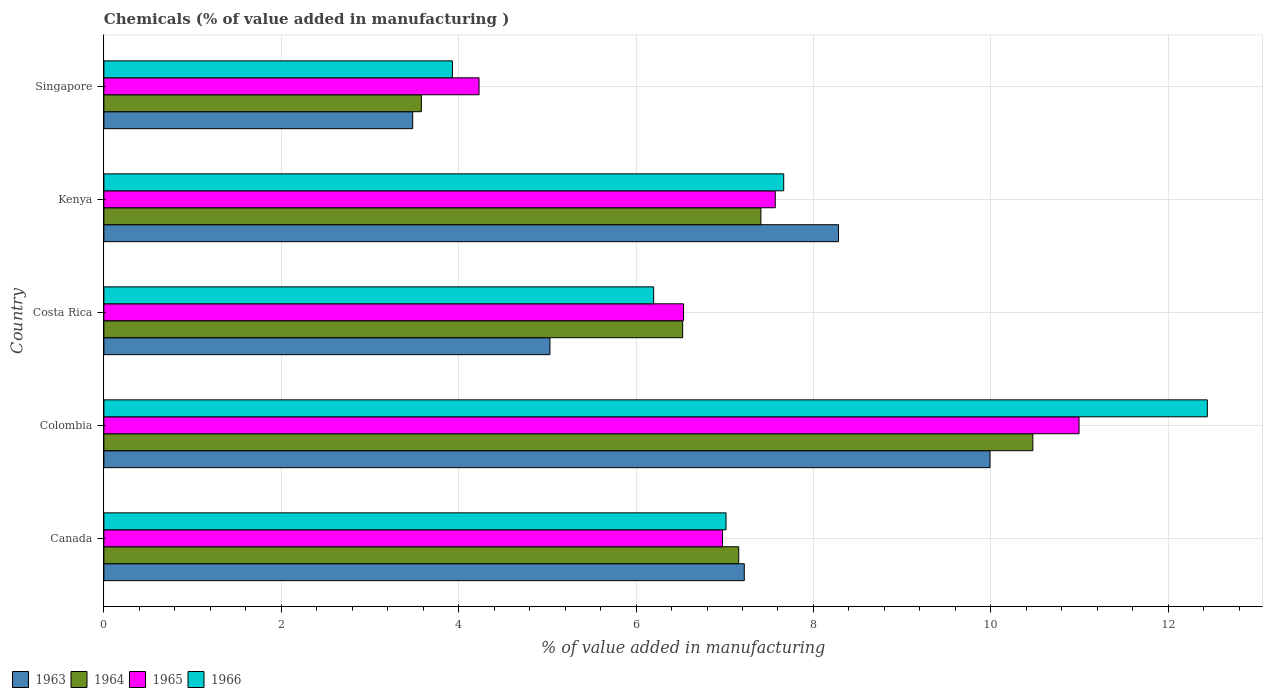How many different coloured bars are there?
Ensure brevity in your answer.  4. Are the number of bars on each tick of the Y-axis equal?
Make the answer very short. Yes. In how many cases, is the number of bars for a given country not equal to the number of legend labels?
Provide a short and direct response. 0. What is the value added in manufacturing chemicals in 1965 in Costa Rica?
Keep it short and to the point. 6.54. Across all countries, what is the maximum value added in manufacturing chemicals in 1965?
Your response must be concise. 10.99. Across all countries, what is the minimum value added in manufacturing chemicals in 1965?
Offer a very short reply. 4.23. In which country was the value added in manufacturing chemicals in 1963 maximum?
Offer a terse response. Colombia. In which country was the value added in manufacturing chemicals in 1965 minimum?
Offer a terse response. Singapore. What is the total value added in manufacturing chemicals in 1963 in the graph?
Give a very brief answer. 34.01. What is the difference between the value added in manufacturing chemicals in 1966 in Canada and that in Kenya?
Provide a succinct answer. -0.65. What is the difference between the value added in manufacturing chemicals in 1963 in Kenya and the value added in manufacturing chemicals in 1964 in Canada?
Offer a terse response. 1.12. What is the average value added in manufacturing chemicals in 1963 per country?
Provide a short and direct response. 6.8. What is the difference between the value added in manufacturing chemicals in 1966 and value added in manufacturing chemicals in 1965 in Canada?
Ensure brevity in your answer.  0.04. What is the ratio of the value added in manufacturing chemicals in 1966 in Kenya to that in Singapore?
Provide a short and direct response. 1.95. Is the difference between the value added in manufacturing chemicals in 1966 in Colombia and Kenya greater than the difference between the value added in manufacturing chemicals in 1965 in Colombia and Kenya?
Provide a short and direct response. Yes. What is the difference between the highest and the second highest value added in manufacturing chemicals in 1963?
Make the answer very short. 1.71. What is the difference between the highest and the lowest value added in manufacturing chemicals in 1965?
Provide a succinct answer. 6.76. In how many countries, is the value added in manufacturing chemicals in 1966 greater than the average value added in manufacturing chemicals in 1966 taken over all countries?
Keep it short and to the point. 2. Is the sum of the value added in manufacturing chemicals in 1966 in Colombia and Kenya greater than the maximum value added in manufacturing chemicals in 1963 across all countries?
Your answer should be compact. Yes. What does the 2nd bar from the top in Canada represents?
Ensure brevity in your answer.  1965. Is it the case that in every country, the sum of the value added in manufacturing chemicals in 1966 and value added in manufacturing chemicals in 1963 is greater than the value added in manufacturing chemicals in 1965?
Offer a very short reply. Yes. How many bars are there?
Your answer should be very brief. 20. How many countries are there in the graph?
Offer a terse response. 5. Are the values on the major ticks of X-axis written in scientific E-notation?
Provide a succinct answer. No. Does the graph contain grids?
Provide a short and direct response. Yes. Where does the legend appear in the graph?
Ensure brevity in your answer.  Bottom left. What is the title of the graph?
Ensure brevity in your answer.  Chemicals (% of value added in manufacturing ). Does "1984" appear as one of the legend labels in the graph?
Provide a succinct answer. No. What is the label or title of the X-axis?
Make the answer very short. % of value added in manufacturing. What is the % of value added in manufacturing of 1963 in Canada?
Offer a terse response. 7.22. What is the % of value added in manufacturing of 1964 in Canada?
Keep it short and to the point. 7.16. What is the % of value added in manufacturing of 1965 in Canada?
Offer a terse response. 6.98. What is the % of value added in manufacturing of 1966 in Canada?
Provide a short and direct response. 7.01. What is the % of value added in manufacturing in 1963 in Colombia?
Make the answer very short. 9.99. What is the % of value added in manufacturing in 1964 in Colombia?
Offer a very short reply. 10.47. What is the % of value added in manufacturing in 1965 in Colombia?
Give a very brief answer. 10.99. What is the % of value added in manufacturing of 1966 in Colombia?
Give a very brief answer. 12.44. What is the % of value added in manufacturing of 1963 in Costa Rica?
Offer a terse response. 5.03. What is the % of value added in manufacturing in 1964 in Costa Rica?
Your answer should be very brief. 6.53. What is the % of value added in manufacturing of 1965 in Costa Rica?
Your answer should be very brief. 6.54. What is the % of value added in manufacturing of 1966 in Costa Rica?
Offer a very short reply. 6.2. What is the % of value added in manufacturing of 1963 in Kenya?
Keep it short and to the point. 8.28. What is the % of value added in manufacturing in 1964 in Kenya?
Offer a terse response. 7.41. What is the % of value added in manufacturing of 1965 in Kenya?
Provide a short and direct response. 7.57. What is the % of value added in manufacturing of 1966 in Kenya?
Ensure brevity in your answer.  7.67. What is the % of value added in manufacturing in 1963 in Singapore?
Keep it short and to the point. 3.48. What is the % of value added in manufacturing of 1964 in Singapore?
Your response must be concise. 3.58. What is the % of value added in manufacturing in 1965 in Singapore?
Ensure brevity in your answer.  4.23. What is the % of value added in manufacturing of 1966 in Singapore?
Offer a very short reply. 3.93. Across all countries, what is the maximum % of value added in manufacturing in 1963?
Offer a terse response. 9.99. Across all countries, what is the maximum % of value added in manufacturing in 1964?
Offer a terse response. 10.47. Across all countries, what is the maximum % of value added in manufacturing of 1965?
Provide a short and direct response. 10.99. Across all countries, what is the maximum % of value added in manufacturing of 1966?
Make the answer very short. 12.44. Across all countries, what is the minimum % of value added in manufacturing of 1963?
Your answer should be very brief. 3.48. Across all countries, what is the minimum % of value added in manufacturing in 1964?
Offer a very short reply. 3.58. Across all countries, what is the minimum % of value added in manufacturing in 1965?
Your response must be concise. 4.23. Across all countries, what is the minimum % of value added in manufacturing in 1966?
Provide a short and direct response. 3.93. What is the total % of value added in manufacturing of 1963 in the graph?
Give a very brief answer. 34.01. What is the total % of value added in manufacturing in 1964 in the graph?
Keep it short and to the point. 35.15. What is the total % of value added in manufacturing in 1965 in the graph?
Provide a succinct answer. 36.31. What is the total % of value added in manufacturing of 1966 in the graph?
Keep it short and to the point. 37.25. What is the difference between the % of value added in manufacturing in 1963 in Canada and that in Colombia?
Give a very brief answer. -2.77. What is the difference between the % of value added in manufacturing of 1964 in Canada and that in Colombia?
Keep it short and to the point. -3.32. What is the difference between the % of value added in manufacturing in 1965 in Canada and that in Colombia?
Offer a very short reply. -4.02. What is the difference between the % of value added in manufacturing of 1966 in Canada and that in Colombia?
Ensure brevity in your answer.  -5.43. What is the difference between the % of value added in manufacturing of 1963 in Canada and that in Costa Rica?
Provide a succinct answer. 2.19. What is the difference between the % of value added in manufacturing of 1964 in Canada and that in Costa Rica?
Ensure brevity in your answer.  0.63. What is the difference between the % of value added in manufacturing of 1965 in Canada and that in Costa Rica?
Your answer should be very brief. 0.44. What is the difference between the % of value added in manufacturing of 1966 in Canada and that in Costa Rica?
Your answer should be compact. 0.82. What is the difference between the % of value added in manufacturing of 1963 in Canada and that in Kenya?
Offer a terse response. -1.06. What is the difference between the % of value added in manufacturing in 1964 in Canada and that in Kenya?
Offer a terse response. -0.25. What is the difference between the % of value added in manufacturing of 1965 in Canada and that in Kenya?
Provide a short and direct response. -0.59. What is the difference between the % of value added in manufacturing in 1966 in Canada and that in Kenya?
Offer a terse response. -0.65. What is the difference between the % of value added in manufacturing of 1963 in Canada and that in Singapore?
Provide a short and direct response. 3.74. What is the difference between the % of value added in manufacturing in 1964 in Canada and that in Singapore?
Your answer should be very brief. 3.58. What is the difference between the % of value added in manufacturing in 1965 in Canada and that in Singapore?
Your answer should be very brief. 2.75. What is the difference between the % of value added in manufacturing in 1966 in Canada and that in Singapore?
Your answer should be very brief. 3.08. What is the difference between the % of value added in manufacturing of 1963 in Colombia and that in Costa Rica?
Your response must be concise. 4.96. What is the difference between the % of value added in manufacturing of 1964 in Colombia and that in Costa Rica?
Make the answer very short. 3.95. What is the difference between the % of value added in manufacturing of 1965 in Colombia and that in Costa Rica?
Provide a short and direct response. 4.46. What is the difference between the % of value added in manufacturing of 1966 in Colombia and that in Costa Rica?
Your response must be concise. 6.24. What is the difference between the % of value added in manufacturing in 1963 in Colombia and that in Kenya?
Your response must be concise. 1.71. What is the difference between the % of value added in manufacturing in 1964 in Colombia and that in Kenya?
Provide a short and direct response. 3.07. What is the difference between the % of value added in manufacturing in 1965 in Colombia and that in Kenya?
Your answer should be very brief. 3.43. What is the difference between the % of value added in manufacturing of 1966 in Colombia and that in Kenya?
Make the answer very short. 4.78. What is the difference between the % of value added in manufacturing in 1963 in Colombia and that in Singapore?
Your response must be concise. 6.51. What is the difference between the % of value added in manufacturing of 1964 in Colombia and that in Singapore?
Make the answer very short. 6.89. What is the difference between the % of value added in manufacturing of 1965 in Colombia and that in Singapore?
Your answer should be compact. 6.76. What is the difference between the % of value added in manufacturing of 1966 in Colombia and that in Singapore?
Provide a short and direct response. 8.51. What is the difference between the % of value added in manufacturing in 1963 in Costa Rica and that in Kenya?
Provide a succinct answer. -3.25. What is the difference between the % of value added in manufacturing of 1964 in Costa Rica and that in Kenya?
Provide a short and direct response. -0.88. What is the difference between the % of value added in manufacturing of 1965 in Costa Rica and that in Kenya?
Offer a terse response. -1.03. What is the difference between the % of value added in manufacturing in 1966 in Costa Rica and that in Kenya?
Offer a very short reply. -1.47. What is the difference between the % of value added in manufacturing of 1963 in Costa Rica and that in Singapore?
Your answer should be compact. 1.55. What is the difference between the % of value added in manufacturing of 1964 in Costa Rica and that in Singapore?
Your response must be concise. 2.95. What is the difference between the % of value added in manufacturing of 1965 in Costa Rica and that in Singapore?
Offer a terse response. 2.31. What is the difference between the % of value added in manufacturing in 1966 in Costa Rica and that in Singapore?
Your answer should be very brief. 2.27. What is the difference between the % of value added in manufacturing in 1963 in Kenya and that in Singapore?
Provide a short and direct response. 4.8. What is the difference between the % of value added in manufacturing in 1964 in Kenya and that in Singapore?
Provide a succinct answer. 3.83. What is the difference between the % of value added in manufacturing of 1965 in Kenya and that in Singapore?
Make the answer very short. 3.34. What is the difference between the % of value added in manufacturing in 1966 in Kenya and that in Singapore?
Ensure brevity in your answer.  3.74. What is the difference between the % of value added in manufacturing of 1963 in Canada and the % of value added in manufacturing of 1964 in Colombia?
Your answer should be compact. -3.25. What is the difference between the % of value added in manufacturing of 1963 in Canada and the % of value added in manufacturing of 1965 in Colombia?
Make the answer very short. -3.77. What is the difference between the % of value added in manufacturing of 1963 in Canada and the % of value added in manufacturing of 1966 in Colombia?
Offer a terse response. -5.22. What is the difference between the % of value added in manufacturing in 1964 in Canada and the % of value added in manufacturing in 1965 in Colombia?
Make the answer very short. -3.84. What is the difference between the % of value added in manufacturing of 1964 in Canada and the % of value added in manufacturing of 1966 in Colombia?
Provide a succinct answer. -5.28. What is the difference between the % of value added in manufacturing of 1965 in Canada and the % of value added in manufacturing of 1966 in Colombia?
Your answer should be very brief. -5.47. What is the difference between the % of value added in manufacturing in 1963 in Canada and the % of value added in manufacturing in 1964 in Costa Rica?
Your answer should be very brief. 0.69. What is the difference between the % of value added in manufacturing of 1963 in Canada and the % of value added in manufacturing of 1965 in Costa Rica?
Ensure brevity in your answer.  0.68. What is the difference between the % of value added in manufacturing of 1963 in Canada and the % of value added in manufacturing of 1966 in Costa Rica?
Your answer should be very brief. 1.02. What is the difference between the % of value added in manufacturing in 1964 in Canada and the % of value added in manufacturing in 1965 in Costa Rica?
Provide a succinct answer. 0.62. What is the difference between the % of value added in manufacturing of 1964 in Canada and the % of value added in manufacturing of 1966 in Costa Rica?
Keep it short and to the point. 0.96. What is the difference between the % of value added in manufacturing of 1965 in Canada and the % of value added in manufacturing of 1966 in Costa Rica?
Give a very brief answer. 0.78. What is the difference between the % of value added in manufacturing in 1963 in Canada and the % of value added in manufacturing in 1964 in Kenya?
Your answer should be compact. -0.19. What is the difference between the % of value added in manufacturing in 1963 in Canada and the % of value added in manufacturing in 1965 in Kenya?
Keep it short and to the point. -0.35. What is the difference between the % of value added in manufacturing in 1963 in Canada and the % of value added in manufacturing in 1966 in Kenya?
Provide a succinct answer. -0.44. What is the difference between the % of value added in manufacturing in 1964 in Canada and the % of value added in manufacturing in 1965 in Kenya?
Offer a very short reply. -0.41. What is the difference between the % of value added in manufacturing of 1964 in Canada and the % of value added in manufacturing of 1966 in Kenya?
Keep it short and to the point. -0.51. What is the difference between the % of value added in manufacturing of 1965 in Canada and the % of value added in manufacturing of 1966 in Kenya?
Your answer should be very brief. -0.69. What is the difference between the % of value added in manufacturing in 1963 in Canada and the % of value added in manufacturing in 1964 in Singapore?
Make the answer very short. 3.64. What is the difference between the % of value added in manufacturing of 1963 in Canada and the % of value added in manufacturing of 1965 in Singapore?
Offer a terse response. 2.99. What is the difference between the % of value added in manufacturing in 1963 in Canada and the % of value added in manufacturing in 1966 in Singapore?
Give a very brief answer. 3.29. What is the difference between the % of value added in manufacturing in 1964 in Canada and the % of value added in manufacturing in 1965 in Singapore?
Keep it short and to the point. 2.93. What is the difference between the % of value added in manufacturing in 1964 in Canada and the % of value added in manufacturing in 1966 in Singapore?
Your answer should be very brief. 3.23. What is the difference between the % of value added in manufacturing of 1965 in Canada and the % of value added in manufacturing of 1966 in Singapore?
Your answer should be very brief. 3.05. What is the difference between the % of value added in manufacturing of 1963 in Colombia and the % of value added in manufacturing of 1964 in Costa Rica?
Offer a terse response. 3.47. What is the difference between the % of value added in manufacturing of 1963 in Colombia and the % of value added in manufacturing of 1965 in Costa Rica?
Ensure brevity in your answer.  3.46. What is the difference between the % of value added in manufacturing of 1963 in Colombia and the % of value added in manufacturing of 1966 in Costa Rica?
Make the answer very short. 3.79. What is the difference between the % of value added in manufacturing in 1964 in Colombia and the % of value added in manufacturing in 1965 in Costa Rica?
Your answer should be compact. 3.94. What is the difference between the % of value added in manufacturing of 1964 in Colombia and the % of value added in manufacturing of 1966 in Costa Rica?
Provide a succinct answer. 4.28. What is the difference between the % of value added in manufacturing in 1965 in Colombia and the % of value added in manufacturing in 1966 in Costa Rica?
Offer a terse response. 4.8. What is the difference between the % of value added in manufacturing of 1963 in Colombia and the % of value added in manufacturing of 1964 in Kenya?
Your answer should be compact. 2.58. What is the difference between the % of value added in manufacturing of 1963 in Colombia and the % of value added in manufacturing of 1965 in Kenya?
Your answer should be very brief. 2.42. What is the difference between the % of value added in manufacturing of 1963 in Colombia and the % of value added in manufacturing of 1966 in Kenya?
Your answer should be very brief. 2.33. What is the difference between the % of value added in manufacturing of 1964 in Colombia and the % of value added in manufacturing of 1965 in Kenya?
Your answer should be very brief. 2.9. What is the difference between the % of value added in manufacturing of 1964 in Colombia and the % of value added in manufacturing of 1966 in Kenya?
Give a very brief answer. 2.81. What is the difference between the % of value added in manufacturing of 1965 in Colombia and the % of value added in manufacturing of 1966 in Kenya?
Your answer should be compact. 3.33. What is the difference between the % of value added in manufacturing in 1963 in Colombia and the % of value added in manufacturing in 1964 in Singapore?
Your answer should be compact. 6.41. What is the difference between the % of value added in manufacturing of 1963 in Colombia and the % of value added in manufacturing of 1965 in Singapore?
Make the answer very short. 5.76. What is the difference between the % of value added in manufacturing of 1963 in Colombia and the % of value added in manufacturing of 1966 in Singapore?
Offer a terse response. 6.06. What is the difference between the % of value added in manufacturing in 1964 in Colombia and the % of value added in manufacturing in 1965 in Singapore?
Give a very brief answer. 6.24. What is the difference between the % of value added in manufacturing in 1964 in Colombia and the % of value added in manufacturing in 1966 in Singapore?
Offer a terse response. 6.54. What is the difference between the % of value added in manufacturing in 1965 in Colombia and the % of value added in manufacturing in 1966 in Singapore?
Offer a very short reply. 7.07. What is the difference between the % of value added in manufacturing of 1963 in Costa Rica and the % of value added in manufacturing of 1964 in Kenya?
Your response must be concise. -2.38. What is the difference between the % of value added in manufacturing of 1963 in Costa Rica and the % of value added in manufacturing of 1965 in Kenya?
Offer a very short reply. -2.54. What is the difference between the % of value added in manufacturing in 1963 in Costa Rica and the % of value added in manufacturing in 1966 in Kenya?
Provide a short and direct response. -2.64. What is the difference between the % of value added in manufacturing in 1964 in Costa Rica and the % of value added in manufacturing in 1965 in Kenya?
Give a very brief answer. -1.04. What is the difference between the % of value added in manufacturing of 1964 in Costa Rica and the % of value added in manufacturing of 1966 in Kenya?
Your answer should be compact. -1.14. What is the difference between the % of value added in manufacturing of 1965 in Costa Rica and the % of value added in manufacturing of 1966 in Kenya?
Give a very brief answer. -1.13. What is the difference between the % of value added in manufacturing in 1963 in Costa Rica and the % of value added in manufacturing in 1964 in Singapore?
Your response must be concise. 1.45. What is the difference between the % of value added in manufacturing of 1963 in Costa Rica and the % of value added in manufacturing of 1965 in Singapore?
Your response must be concise. 0.8. What is the difference between the % of value added in manufacturing of 1963 in Costa Rica and the % of value added in manufacturing of 1966 in Singapore?
Your response must be concise. 1.1. What is the difference between the % of value added in manufacturing of 1964 in Costa Rica and the % of value added in manufacturing of 1965 in Singapore?
Provide a succinct answer. 2.3. What is the difference between the % of value added in manufacturing in 1964 in Costa Rica and the % of value added in manufacturing in 1966 in Singapore?
Offer a terse response. 2.6. What is the difference between the % of value added in manufacturing of 1965 in Costa Rica and the % of value added in manufacturing of 1966 in Singapore?
Ensure brevity in your answer.  2.61. What is the difference between the % of value added in manufacturing of 1963 in Kenya and the % of value added in manufacturing of 1964 in Singapore?
Offer a very short reply. 4.7. What is the difference between the % of value added in manufacturing in 1963 in Kenya and the % of value added in manufacturing in 1965 in Singapore?
Your answer should be very brief. 4.05. What is the difference between the % of value added in manufacturing in 1963 in Kenya and the % of value added in manufacturing in 1966 in Singapore?
Your answer should be compact. 4.35. What is the difference between the % of value added in manufacturing of 1964 in Kenya and the % of value added in manufacturing of 1965 in Singapore?
Provide a short and direct response. 3.18. What is the difference between the % of value added in manufacturing of 1964 in Kenya and the % of value added in manufacturing of 1966 in Singapore?
Your answer should be compact. 3.48. What is the difference between the % of value added in manufacturing of 1965 in Kenya and the % of value added in manufacturing of 1966 in Singapore?
Your answer should be very brief. 3.64. What is the average % of value added in manufacturing in 1963 per country?
Keep it short and to the point. 6.8. What is the average % of value added in manufacturing in 1964 per country?
Keep it short and to the point. 7.03. What is the average % of value added in manufacturing of 1965 per country?
Your answer should be compact. 7.26. What is the average % of value added in manufacturing in 1966 per country?
Give a very brief answer. 7.45. What is the difference between the % of value added in manufacturing in 1963 and % of value added in manufacturing in 1964 in Canada?
Give a very brief answer. 0.06. What is the difference between the % of value added in manufacturing of 1963 and % of value added in manufacturing of 1965 in Canada?
Keep it short and to the point. 0.25. What is the difference between the % of value added in manufacturing of 1963 and % of value added in manufacturing of 1966 in Canada?
Offer a terse response. 0.21. What is the difference between the % of value added in manufacturing of 1964 and % of value added in manufacturing of 1965 in Canada?
Your answer should be very brief. 0.18. What is the difference between the % of value added in manufacturing in 1964 and % of value added in manufacturing in 1966 in Canada?
Offer a terse response. 0.14. What is the difference between the % of value added in manufacturing in 1965 and % of value added in manufacturing in 1966 in Canada?
Offer a very short reply. -0.04. What is the difference between the % of value added in manufacturing of 1963 and % of value added in manufacturing of 1964 in Colombia?
Offer a terse response. -0.48. What is the difference between the % of value added in manufacturing in 1963 and % of value added in manufacturing in 1965 in Colombia?
Offer a very short reply. -1. What is the difference between the % of value added in manufacturing of 1963 and % of value added in manufacturing of 1966 in Colombia?
Your response must be concise. -2.45. What is the difference between the % of value added in manufacturing in 1964 and % of value added in manufacturing in 1965 in Colombia?
Offer a very short reply. -0.52. What is the difference between the % of value added in manufacturing of 1964 and % of value added in manufacturing of 1966 in Colombia?
Ensure brevity in your answer.  -1.97. What is the difference between the % of value added in manufacturing in 1965 and % of value added in manufacturing in 1966 in Colombia?
Give a very brief answer. -1.45. What is the difference between the % of value added in manufacturing in 1963 and % of value added in manufacturing in 1964 in Costa Rica?
Make the answer very short. -1.5. What is the difference between the % of value added in manufacturing of 1963 and % of value added in manufacturing of 1965 in Costa Rica?
Provide a short and direct response. -1.51. What is the difference between the % of value added in manufacturing of 1963 and % of value added in manufacturing of 1966 in Costa Rica?
Provide a succinct answer. -1.17. What is the difference between the % of value added in manufacturing of 1964 and % of value added in manufacturing of 1965 in Costa Rica?
Make the answer very short. -0.01. What is the difference between the % of value added in manufacturing in 1964 and % of value added in manufacturing in 1966 in Costa Rica?
Make the answer very short. 0.33. What is the difference between the % of value added in manufacturing in 1965 and % of value added in manufacturing in 1966 in Costa Rica?
Provide a short and direct response. 0.34. What is the difference between the % of value added in manufacturing in 1963 and % of value added in manufacturing in 1964 in Kenya?
Provide a short and direct response. 0.87. What is the difference between the % of value added in manufacturing in 1963 and % of value added in manufacturing in 1965 in Kenya?
Make the answer very short. 0.71. What is the difference between the % of value added in manufacturing of 1963 and % of value added in manufacturing of 1966 in Kenya?
Your answer should be very brief. 0.62. What is the difference between the % of value added in manufacturing in 1964 and % of value added in manufacturing in 1965 in Kenya?
Your response must be concise. -0.16. What is the difference between the % of value added in manufacturing of 1964 and % of value added in manufacturing of 1966 in Kenya?
Offer a terse response. -0.26. What is the difference between the % of value added in manufacturing of 1965 and % of value added in manufacturing of 1966 in Kenya?
Give a very brief answer. -0.1. What is the difference between the % of value added in manufacturing in 1963 and % of value added in manufacturing in 1964 in Singapore?
Provide a succinct answer. -0.1. What is the difference between the % of value added in manufacturing in 1963 and % of value added in manufacturing in 1965 in Singapore?
Provide a short and direct response. -0.75. What is the difference between the % of value added in manufacturing of 1963 and % of value added in manufacturing of 1966 in Singapore?
Offer a terse response. -0.45. What is the difference between the % of value added in manufacturing of 1964 and % of value added in manufacturing of 1965 in Singapore?
Offer a terse response. -0.65. What is the difference between the % of value added in manufacturing of 1964 and % of value added in manufacturing of 1966 in Singapore?
Ensure brevity in your answer.  -0.35. What is the difference between the % of value added in manufacturing in 1965 and % of value added in manufacturing in 1966 in Singapore?
Your response must be concise. 0.3. What is the ratio of the % of value added in manufacturing of 1963 in Canada to that in Colombia?
Give a very brief answer. 0.72. What is the ratio of the % of value added in manufacturing in 1964 in Canada to that in Colombia?
Your answer should be compact. 0.68. What is the ratio of the % of value added in manufacturing of 1965 in Canada to that in Colombia?
Keep it short and to the point. 0.63. What is the ratio of the % of value added in manufacturing of 1966 in Canada to that in Colombia?
Your answer should be compact. 0.56. What is the ratio of the % of value added in manufacturing of 1963 in Canada to that in Costa Rica?
Keep it short and to the point. 1.44. What is the ratio of the % of value added in manufacturing in 1964 in Canada to that in Costa Rica?
Offer a very short reply. 1.1. What is the ratio of the % of value added in manufacturing in 1965 in Canada to that in Costa Rica?
Your answer should be compact. 1.07. What is the ratio of the % of value added in manufacturing in 1966 in Canada to that in Costa Rica?
Provide a short and direct response. 1.13. What is the ratio of the % of value added in manufacturing of 1963 in Canada to that in Kenya?
Provide a succinct answer. 0.87. What is the ratio of the % of value added in manufacturing of 1964 in Canada to that in Kenya?
Make the answer very short. 0.97. What is the ratio of the % of value added in manufacturing of 1965 in Canada to that in Kenya?
Keep it short and to the point. 0.92. What is the ratio of the % of value added in manufacturing in 1966 in Canada to that in Kenya?
Offer a terse response. 0.92. What is the ratio of the % of value added in manufacturing of 1963 in Canada to that in Singapore?
Offer a very short reply. 2.07. What is the ratio of the % of value added in manufacturing of 1964 in Canada to that in Singapore?
Offer a very short reply. 2. What is the ratio of the % of value added in manufacturing in 1965 in Canada to that in Singapore?
Your response must be concise. 1.65. What is the ratio of the % of value added in manufacturing in 1966 in Canada to that in Singapore?
Offer a terse response. 1.78. What is the ratio of the % of value added in manufacturing of 1963 in Colombia to that in Costa Rica?
Give a very brief answer. 1.99. What is the ratio of the % of value added in manufacturing in 1964 in Colombia to that in Costa Rica?
Your response must be concise. 1.61. What is the ratio of the % of value added in manufacturing of 1965 in Colombia to that in Costa Rica?
Ensure brevity in your answer.  1.68. What is the ratio of the % of value added in manufacturing of 1966 in Colombia to that in Costa Rica?
Offer a terse response. 2.01. What is the ratio of the % of value added in manufacturing of 1963 in Colombia to that in Kenya?
Offer a terse response. 1.21. What is the ratio of the % of value added in manufacturing in 1964 in Colombia to that in Kenya?
Make the answer very short. 1.41. What is the ratio of the % of value added in manufacturing of 1965 in Colombia to that in Kenya?
Make the answer very short. 1.45. What is the ratio of the % of value added in manufacturing in 1966 in Colombia to that in Kenya?
Your answer should be compact. 1.62. What is the ratio of the % of value added in manufacturing in 1963 in Colombia to that in Singapore?
Make the answer very short. 2.87. What is the ratio of the % of value added in manufacturing of 1964 in Colombia to that in Singapore?
Your answer should be very brief. 2.93. What is the ratio of the % of value added in manufacturing of 1965 in Colombia to that in Singapore?
Provide a short and direct response. 2.6. What is the ratio of the % of value added in manufacturing of 1966 in Colombia to that in Singapore?
Your response must be concise. 3.17. What is the ratio of the % of value added in manufacturing of 1963 in Costa Rica to that in Kenya?
Your response must be concise. 0.61. What is the ratio of the % of value added in manufacturing of 1964 in Costa Rica to that in Kenya?
Offer a terse response. 0.88. What is the ratio of the % of value added in manufacturing in 1965 in Costa Rica to that in Kenya?
Provide a short and direct response. 0.86. What is the ratio of the % of value added in manufacturing of 1966 in Costa Rica to that in Kenya?
Your answer should be very brief. 0.81. What is the ratio of the % of value added in manufacturing of 1963 in Costa Rica to that in Singapore?
Your response must be concise. 1.44. What is the ratio of the % of value added in manufacturing in 1964 in Costa Rica to that in Singapore?
Make the answer very short. 1.82. What is the ratio of the % of value added in manufacturing of 1965 in Costa Rica to that in Singapore?
Give a very brief answer. 1.55. What is the ratio of the % of value added in manufacturing of 1966 in Costa Rica to that in Singapore?
Give a very brief answer. 1.58. What is the ratio of the % of value added in manufacturing in 1963 in Kenya to that in Singapore?
Provide a succinct answer. 2.38. What is the ratio of the % of value added in manufacturing in 1964 in Kenya to that in Singapore?
Your answer should be compact. 2.07. What is the ratio of the % of value added in manufacturing of 1965 in Kenya to that in Singapore?
Your answer should be very brief. 1.79. What is the ratio of the % of value added in manufacturing of 1966 in Kenya to that in Singapore?
Your response must be concise. 1.95. What is the difference between the highest and the second highest % of value added in manufacturing in 1963?
Offer a very short reply. 1.71. What is the difference between the highest and the second highest % of value added in manufacturing in 1964?
Offer a terse response. 3.07. What is the difference between the highest and the second highest % of value added in manufacturing of 1965?
Offer a very short reply. 3.43. What is the difference between the highest and the second highest % of value added in manufacturing of 1966?
Make the answer very short. 4.78. What is the difference between the highest and the lowest % of value added in manufacturing of 1963?
Your answer should be compact. 6.51. What is the difference between the highest and the lowest % of value added in manufacturing in 1964?
Keep it short and to the point. 6.89. What is the difference between the highest and the lowest % of value added in manufacturing of 1965?
Provide a succinct answer. 6.76. What is the difference between the highest and the lowest % of value added in manufacturing in 1966?
Make the answer very short. 8.51. 